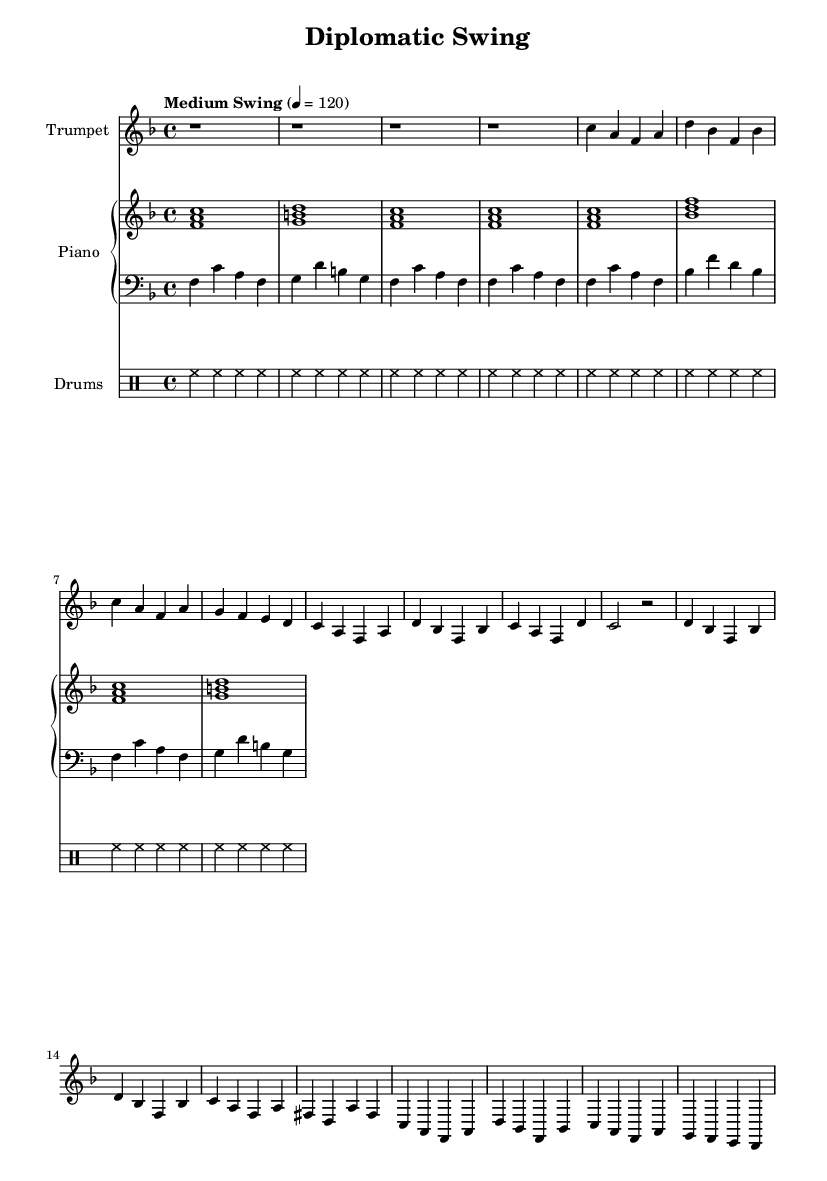What is the key signature of this music? The key signature is F major, which has one flat (B flat). This is identified by looking at the beginning of the sheet music where the key signature is notated.
Answer: F major What is the time signature of this piece? The time signature is 4/4, which can be found near the beginning of the sheet music. It signifies that there are four beats in each measure, and the quarter note gets one beat.
Answer: 4/4 What is the tempo marking for this music? The tempo marking is "Medium Swing" at a speed of 120 beats per minute. This is indicated in the tempo instructions found at the start of the score, informing the musicians how fast to play.
Answer: Medium Swing 4 = 120 How many measures are in the A section of the composition? The A section consists of 8 measures, identifiable by counting each distinct measure group found in the A section labeled within the sheet music, before transitioning to the B section.
Answer: 8 What instruments are involved in this piece? The piece is scored for trumpet, piano, bass, and drums. This can be determined by looking at the instrumental names on each staff at the beginning of the score, indicating the parts being played.
Answer: Trumpet, Piano, Bass, Drums Which section contains a repeat of the A section? The B section does not revisit A directly, but the A section is partially repeated before it. This requires a comparison of the notation in the score, where the second half of the A section mirrors the first.
Answer: A section (partial) What style of jazz does this piece represent? This piece represents upbeat swing jazz, characterized by its joyful tempo and rhythmic feel typical of the swing style, illustrated through the rhythmic patterns and tempo markings given throughout the music.
Answer: Upbeat swing jazz 